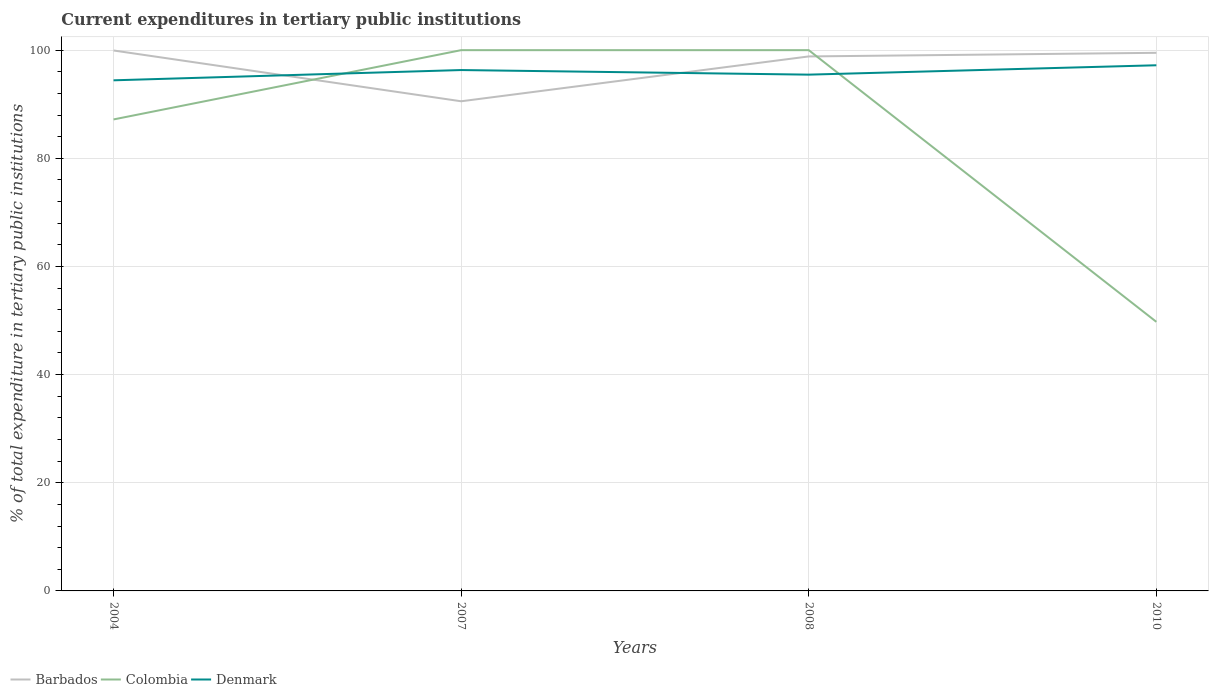Does the line corresponding to Denmark intersect with the line corresponding to Barbados?
Make the answer very short. Yes. Is the number of lines equal to the number of legend labels?
Offer a terse response. Yes. Across all years, what is the maximum current expenditures in tertiary public institutions in Barbados?
Ensure brevity in your answer.  90.55. What is the total current expenditures in tertiary public institutions in Colombia in the graph?
Give a very brief answer. 50.24. What is the difference between the highest and the second highest current expenditures in tertiary public institutions in Colombia?
Your response must be concise. 50.24. What is the difference between the highest and the lowest current expenditures in tertiary public institutions in Colombia?
Offer a terse response. 3. Is the current expenditures in tertiary public institutions in Barbados strictly greater than the current expenditures in tertiary public institutions in Colombia over the years?
Give a very brief answer. No. How many lines are there?
Your answer should be compact. 3. How many years are there in the graph?
Ensure brevity in your answer.  4. Are the values on the major ticks of Y-axis written in scientific E-notation?
Your answer should be compact. No. Does the graph contain any zero values?
Offer a very short reply. No. How many legend labels are there?
Keep it short and to the point. 3. What is the title of the graph?
Provide a succinct answer. Current expenditures in tertiary public institutions. Does "Ukraine" appear as one of the legend labels in the graph?
Your answer should be very brief. No. What is the label or title of the Y-axis?
Your answer should be compact. % of total expenditure in tertiary public institutions. What is the % of total expenditure in tertiary public institutions of Barbados in 2004?
Ensure brevity in your answer.  99.94. What is the % of total expenditure in tertiary public institutions in Colombia in 2004?
Offer a terse response. 87.19. What is the % of total expenditure in tertiary public institutions of Denmark in 2004?
Offer a terse response. 94.42. What is the % of total expenditure in tertiary public institutions in Barbados in 2007?
Ensure brevity in your answer.  90.55. What is the % of total expenditure in tertiary public institutions of Denmark in 2007?
Your answer should be compact. 96.32. What is the % of total expenditure in tertiary public institutions in Barbados in 2008?
Offer a very short reply. 98.84. What is the % of total expenditure in tertiary public institutions of Denmark in 2008?
Your answer should be very brief. 95.47. What is the % of total expenditure in tertiary public institutions of Barbados in 2010?
Provide a succinct answer. 99.51. What is the % of total expenditure in tertiary public institutions of Colombia in 2010?
Keep it short and to the point. 49.76. What is the % of total expenditure in tertiary public institutions in Denmark in 2010?
Provide a short and direct response. 97.21. Across all years, what is the maximum % of total expenditure in tertiary public institutions of Barbados?
Make the answer very short. 99.94. Across all years, what is the maximum % of total expenditure in tertiary public institutions of Denmark?
Your answer should be compact. 97.21. Across all years, what is the minimum % of total expenditure in tertiary public institutions of Barbados?
Offer a very short reply. 90.55. Across all years, what is the minimum % of total expenditure in tertiary public institutions of Colombia?
Ensure brevity in your answer.  49.76. Across all years, what is the minimum % of total expenditure in tertiary public institutions of Denmark?
Your answer should be very brief. 94.42. What is the total % of total expenditure in tertiary public institutions of Barbados in the graph?
Your response must be concise. 388.84. What is the total % of total expenditure in tertiary public institutions of Colombia in the graph?
Provide a succinct answer. 336.95. What is the total % of total expenditure in tertiary public institutions in Denmark in the graph?
Your answer should be compact. 383.42. What is the difference between the % of total expenditure in tertiary public institutions in Barbados in 2004 and that in 2007?
Your answer should be very brief. 9.39. What is the difference between the % of total expenditure in tertiary public institutions of Colombia in 2004 and that in 2007?
Make the answer very short. -12.81. What is the difference between the % of total expenditure in tertiary public institutions of Denmark in 2004 and that in 2007?
Give a very brief answer. -1.9. What is the difference between the % of total expenditure in tertiary public institutions of Barbados in 2004 and that in 2008?
Provide a succinct answer. 1.1. What is the difference between the % of total expenditure in tertiary public institutions in Colombia in 2004 and that in 2008?
Your response must be concise. -12.81. What is the difference between the % of total expenditure in tertiary public institutions in Denmark in 2004 and that in 2008?
Ensure brevity in your answer.  -1.05. What is the difference between the % of total expenditure in tertiary public institutions of Barbados in 2004 and that in 2010?
Offer a terse response. 0.43. What is the difference between the % of total expenditure in tertiary public institutions of Colombia in 2004 and that in 2010?
Offer a terse response. 37.43. What is the difference between the % of total expenditure in tertiary public institutions in Denmark in 2004 and that in 2010?
Your response must be concise. -2.78. What is the difference between the % of total expenditure in tertiary public institutions of Barbados in 2007 and that in 2008?
Your response must be concise. -8.29. What is the difference between the % of total expenditure in tertiary public institutions of Colombia in 2007 and that in 2008?
Offer a terse response. 0. What is the difference between the % of total expenditure in tertiary public institutions of Denmark in 2007 and that in 2008?
Ensure brevity in your answer.  0.85. What is the difference between the % of total expenditure in tertiary public institutions in Barbados in 2007 and that in 2010?
Keep it short and to the point. -8.96. What is the difference between the % of total expenditure in tertiary public institutions in Colombia in 2007 and that in 2010?
Offer a terse response. 50.24. What is the difference between the % of total expenditure in tertiary public institutions in Denmark in 2007 and that in 2010?
Your answer should be compact. -0.89. What is the difference between the % of total expenditure in tertiary public institutions of Barbados in 2008 and that in 2010?
Keep it short and to the point. -0.67. What is the difference between the % of total expenditure in tertiary public institutions of Colombia in 2008 and that in 2010?
Make the answer very short. 50.24. What is the difference between the % of total expenditure in tertiary public institutions of Denmark in 2008 and that in 2010?
Offer a terse response. -1.74. What is the difference between the % of total expenditure in tertiary public institutions of Barbados in 2004 and the % of total expenditure in tertiary public institutions of Colombia in 2007?
Provide a short and direct response. -0.06. What is the difference between the % of total expenditure in tertiary public institutions in Barbados in 2004 and the % of total expenditure in tertiary public institutions in Denmark in 2007?
Your response must be concise. 3.62. What is the difference between the % of total expenditure in tertiary public institutions in Colombia in 2004 and the % of total expenditure in tertiary public institutions in Denmark in 2007?
Ensure brevity in your answer.  -9.13. What is the difference between the % of total expenditure in tertiary public institutions in Barbados in 2004 and the % of total expenditure in tertiary public institutions in Colombia in 2008?
Your answer should be compact. -0.06. What is the difference between the % of total expenditure in tertiary public institutions in Barbados in 2004 and the % of total expenditure in tertiary public institutions in Denmark in 2008?
Ensure brevity in your answer.  4.47. What is the difference between the % of total expenditure in tertiary public institutions of Colombia in 2004 and the % of total expenditure in tertiary public institutions of Denmark in 2008?
Your answer should be compact. -8.28. What is the difference between the % of total expenditure in tertiary public institutions in Barbados in 2004 and the % of total expenditure in tertiary public institutions in Colombia in 2010?
Give a very brief answer. 50.18. What is the difference between the % of total expenditure in tertiary public institutions in Barbados in 2004 and the % of total expenditure in tertiary public institutions in Denmark in 2010?
Ensure brevity in your answer.  2.73. What is the difference between the % of total expenditure in tertiary public institutions in Colombia in 2004 and the % of total expenditure in tertiary public institutions in Denmark in 2010?
Keep it short and to the point. -10.02. What is the difference between the % of total expenditure in tertiary public institutions in Barbados in 2007 and the % of total expenditure in tertiary public institutions in Colombia in 2008?
Your response must be concise. -9.45. What is the difference between the % of total expenditure in tertiary public institutions in Barbados in 2007 and the % of total expenditure in tertiary public institutions in Denmark in 2008?
Give a very brief answer. -4.92. What is the difference between the % of total expenditure in tertiary public institutions in Colombia in 2007 and the % of total expenditure in tertiary public institutions in Denmark in 2008?
Your answer should be very brief. 4.53. What is the difference between the % of total expenditure in tertiary public institutions in Barbados in 2007 and the % of total expenditure in tertiary public institutions in Colombia in 2010?
Provide a succinct answer. 40.79. What is the difference between the % of total expenditure in tertiary public institutions of Barbados in 2007 and the % of total expenditure in tertiary public institutions of Denmark in 2010?
Your answer should be compact. -6.66. What is the difference between the % of total expenditure in tertiary public institutions in Colombia in 2007 and the % of total expenditure in tertiary public institutions in Denmark in 2010?
Provide a succinct answer. 2.79. What is the difference between the % of total expenditure in tertiary public institutions of Barbados in 2008 and the % of total expenditure in tertiary public institutions of Colombia in 2010?
Offer a very short reply. 49.08. What is the difference between the % of total expenditure in tertiary public institutions in Barbados in 2008 and the % of total expenditure in tertiary public institutions in Denmark in 2010?
Your answer should be very brief. 1.63. What is the difference between the % of total expenditure in tertiary public institutions of Colombia in 2008 and the % of total expenditure in tertiary public institutions of Denmark in 2010?
Give a very brief answer. 2.79. What is the average % of total expenditure in tertiary public institutions of Barbados per year?
Provide a short and direct response. 97.21. What is the average % of total expenditure in tertiary public institutions in Colombia per year?
Your answer should be compact. 84.24. What is the average % of total expenditure in tertiary public institutions in Denmark per year?
Make the answer very short. 95.86. In the year 2004, what is the difference between the % of total expenditure in tertiary public institutions of Barbados and % of total expenditure in tertiary public institutions of Colombia?
Offer a terse response. 12.75. In the year 2004, what is the difference between the % of total expenditure in tertiary public institutions in Barbados and % of total expenditure in tertiary public institutions in Denmark?
Make the answer very short. 5.52. In the year 2004, what is the difference between the % of total expenditure in tertiary public institutions in Colombia and % of total expenditure in tertiary public institutions in Denmark?
Offer a very short reply. -7.23. In the year 2007, what is the difference between the % of total expenditure in tertiary public institutions in Barbados and % of total expenditure in tertiary public institutions in Colombia?
Your answer should be compact. -9.45. In the year 2007, what is the difference between the % of total expenditure in tertiary public institutions in Barbados and % of total expenditure in tertiary public institutions in Denmark?
Give a very brief answer. -5.77. In the year 2007, what is the difference between the % of total expenditure in tertiary public institutions of Colombia and % of total expenditure in tertiary public institutions of Denmark?
Make the answer very short. 3.68. In the year 2008, what is the difference between the % of total expenditure in tertiary public institutions in Barbados and % of total expenditure in tertiary public institutions in Colombia?
Your answer should be compact. -1.16. In the year 2008, what is the difference between the % of total expenditure in tertiary public institutions in Barbados and % of total expenditure in tertiary public institutions in Denmark?
Give a very brief answer. 3.37. In the year 2008, what is the difference between the % of total expenditure in tertiary public institutions of Colombia and % of total expenditure in tertiary public institutions of Denmark?
Offer a terse response. 4.53. In the year 2010, what is the difference between the % of total expenditure in tertiary public institutions of Barbados and % of total expenditure in tertiary public institutions of Colombia?
Make the answer very short. 49.75. In the year 2010, what is the difference between the % of total expenditure in tertiary public institutions in Barbados and % of total expenditure in tertiary public institutions in Denmark?
Your response must be concise. 2.3. In the year 2010, what is the difference between the % of total expenditure in tertiary public institutions of Colombia and % of total expenditure in tertiary public institutions of Denmark?
Give a very brief answer. -47.45. What is the ratio of the % of total expenditure in tertiary public institutions in Barbados in 2004 to that in 2007?
Offer a terse response. 1.1. What is the ratio of the % of total expenditure in tertiary public institutions of Colombia in 2004 to that in 2007?
Keep it short and to the point. 0.87. What is the ratio of the % of total expenditure in tertiary public institutions of Denmark in 2004 to that in 2007?
Offer a terse response. 0.98. What is the ratio of the % of total expenditure in tertiary public institutions of Barbados in 2004 to that in 2008?
Ensure brevity in your answer.  1.01. What is the ratio of the % of total expenditure in tertiary public institutions in Colombia in 2004 to that in 2008?
Your response must be concise. 0.87. What is the ratio of the % of total expenditure in tertiary public institutions in Denmark in 2004 to that in 2008?
Keep it short and to the point. 0.99. What is the ratio of the % of total expenditure in tertiary public institutions of Barbados in 2004 to that in 2010?
Your answer should be very brief. 1. What is the ratio of the % of total expenditure in tertiary public institutions of Colombia in 2004 to that in 2010?
Offer a very short reply. 1.75. What is the ratio of the % of total expenditure in tertiary public institutions in Denmark in 2004 to that in 2010?
Your answer should be very brief. 0.97. What is the ratio of the % of total expenditure in tertiary public institutions in Barbados in 2007 to that in 2008?
Your response must be concise. 0.92. What is the ratio of the % of total expenditure in tertiary public institutions in Colombia in 2007 to that in 2008?
Give a very brief answer. 1. What is the ratio of the % of total expenditure in tertiary public institutions of Denmark in 2007 to that in 2008?
Give a very brief answer. 1.01. What is the ratio of the % of total expenditure in tertiary public institutions of Barbados in 2007 to that in 2010?
Your answer should be very brief. 0.91. What is the ratio of the % of total expenditure in tertiary public institutions of Colombia in 2007 to that in 2010?
Ensure brevity in your answer.  2.01. What is the ratio of the % of total expenditure in tertiary public institutions of Denmark in 2007 to that in 2010?
Make the answer very short. 0.99. What is the ratio of the % of total expenditure in tertiary public institutions in Colombia in 2008 to that in 2010?
Provide a short and direct response. 2.01. What is the ratio of the % of total expenditure in tertiary public institutions in Denmark in 2008 to that in 2010?
Offer a terse response. 0.98. What is the difference between the highest and the second highest % of total expenditure in tertiary public institutions in Barbados?
Your response must be concise. 0.43. What is the difference between the highest and the second highest % of total expenditure in tertiary public institutions in Denmark?
Your answer should be compact. 0.89. What is the difference between the highest and the lowest % of total expenditure in tertiary public institutions of Barbados?
Offer a terse response. 9.39. What is the difference between the highest and the lowest % of total expenditure in tertiary public institutions of Colombia?
Your answer should be compact. 50.24. What is the difference between the highest and the lowest % of total expenditure in tertiary public institutions of Denmark?
Offer a very short reply. 2.78. 